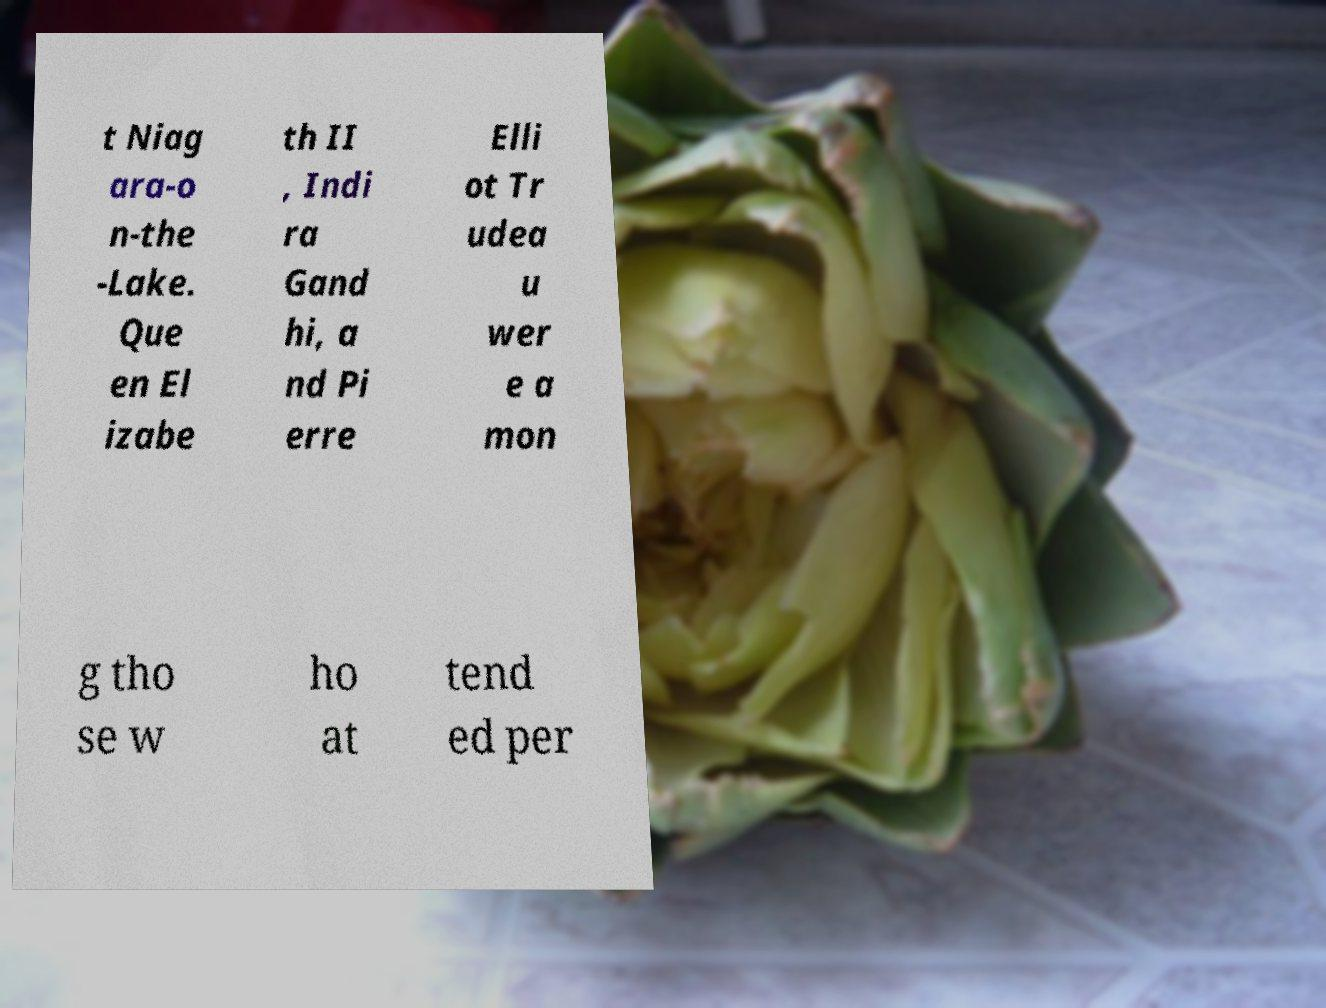Can you accurately transcribe the text from the provided image for me? t Niag ara-o n-the -Lake. Que en El izabe th II , Indi ra Gand hi, a nd Pi erre Elli ot Tr udea u wer e a mon g tho se w ho at tend ed per 